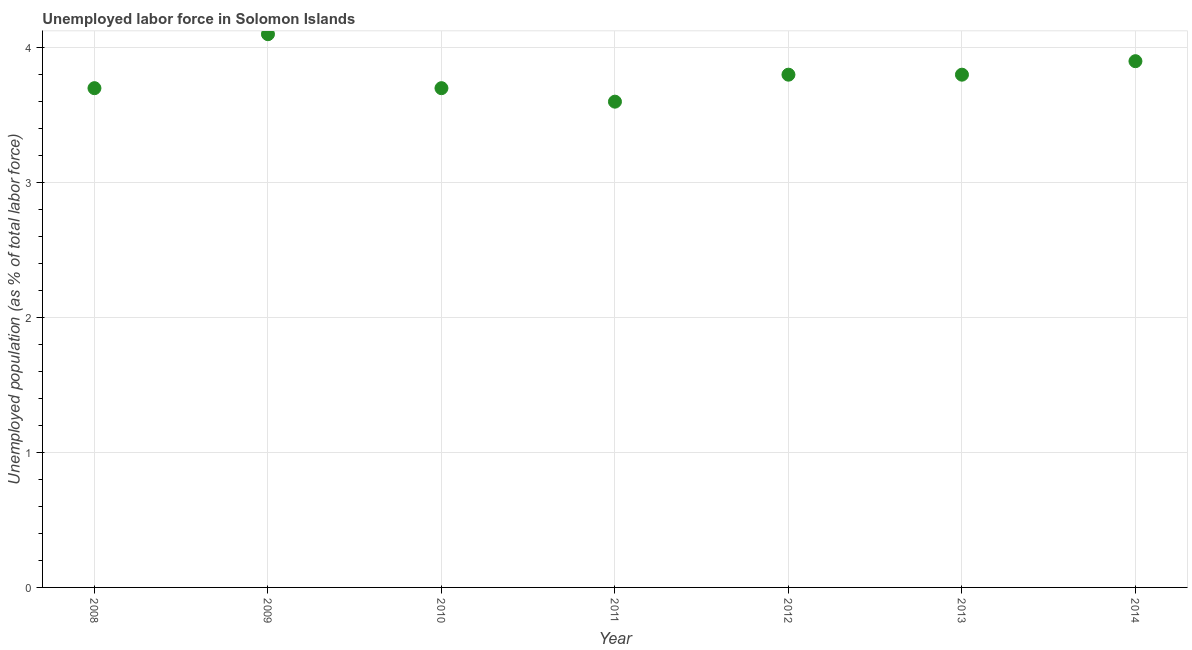What is the total unemployed population in 2014?
Keep it short and to the point. 3.9. Across all years, what is the maximum total unemployed population?
Your answer should be very brief. 4.1. Across all years, what is the minimum total unemployed population?
Your response must be concise. 3.6. In which year was the total unemployed population minimum?
Keep it short and to the point. 2011. What is the sum of the total unemployed population?
Your answer should be very brief. 26.6. What is the difference between the total unemployed population in 2010 and 2011?
Give a very brief answer. 0.1. What is the average total unemployed population per year?
Offer a terse response. 3.8. What is the median total unemployed population?
Offer a terse response. 3.8. What is the ratio of the total unemployed population in 2008 to that in 2014?
Your response must be concise. 0.95. Is the total unemployed population in 2013 less than that in 2014?
Your answer should be very brief. Yes. What is the difference between the highest and the second highest total unemployed population?
Offer a terse response. 0.2. What is the difference between the highest and the lowest total unemployed population?
Provide a short and direct response. 0.5. In how many years, is the total unemployed population greater than the average total unemployed population taken over all years?
Offer a very short reply. 2. Does the total unemployed population monotonically increase over the years?
Keep it short and to the point. No. How many dotlines are there?
Your answer should be very brief. 1. How many years are there in the graph?
Provide a succinct answer. 7. What is the difference between two consecutive major ticks on the Y-axis?
Ensure brevity in your answer.  1. Does the graph contain any zero values?
Provide a succinct answer. No. What is the title of the graph?
Offer a very short reply. Unemployed labor force in Solomon Islands. What is the label or title of the Y-axis?
Your answer should be very brief. Unemployed population (as % of total labor force). What is the Unemployed population (as % of total labor force) in 2008?
Your answer should be very brief. 3.7. What is the Unemployed population (as % of total labor force) in 2009?
Your answer should be compact. 4.1. What is the Unemployed population (as % of total labor force) in 2010?
Your response must be concise. 3.7. What is the Unemployed population (as % of total labor force) in 2011?
Offer a very short reply. 3.6. What is the Unemployed population (as % of total labor force) in 2012?
Your answer should be very brief. 3.8. What is the Unemployed population (as % of total labor force) in 2013?
Give a very brief answer. 3.8. What is the Unemployed population (as % of total labor force) in 2014?
Keep it short and to the point. 3.9. What is the difference between the Unemployed population (as % of total labor force) in 2008 and 2009?
Ensure brevity in your answer.  -0.4. What is the difference between the Unemployed population (as % of total labor force) in 2008 and 2014?
Provide a short and direct response. -0.2. What is the difference between the Unemployed population (as % of total labor force) in 2009 and 2010?
Offer a terse response. 0.4. What is the difference between the Unemployed population (as % of total labor force) in 2009 and 2013?
Your answer should be compact. 0.3. What is the difference between the Unemployed population (as % of total labor force) in 2009 and 2014?
Give a very brief answer. 0.2. What is the difference between the Unemployed population (as % of total labor force) in 2011 and 2012?
Ensure brevity in your answer.  -0.2. What is the difference between the Unemployed population (as % of total labor force) in 2012 and 2013?
Ensure brevity in your answer.  0. What is the difference between the Unemployed population (as % of total labor force) in 2013 and 2014?
Keep it short and to the point. -0.1. What is the ratio of the Unemployed population (as % of total labor force) in 2008 to that in 2009?
Your answer should be very brief. 0.9. What is the ratio of the Unemployed population (as % of total labor force) in 2008 to that in 2010?
Provide a short and direct response. 1. What is the ratio of the Unemployed population (as % of total labor force) in 2008 to that in 2011?
Give a very brief answer. 1.03. What is the ratio of the Unemployed population (as % of total labor force) in 2008 to that in 2013?
Your answer should be very brief. 0.97. What is the ratio of the Unemployed population (as % of total labor force) in 2008 to that in 2014?
Ensure brevity in your answer.  0.95. What is the ratio of the Unemployed population (as % of total labor force) in 2009 to that in 2010?
Ensure brevity in your answer.  1.11. What is the ratio of the Unemployed population (as % of total labor force) in 2009 to that in 2011?
Keep it short and to the point. 1.14. What is the ratio of the Unemployed population (as % of total labor force) in 2009 to that in 2012?
Ensure brevity in your answer.  1.08. What is the ratio of the Unemployed population (as % of total labor force) in 2009 to that in 2013?
Ensure brevity in your answer.  1.08. What is the ratio of the Unemployed population (as % of total labor force) in 2009 to that in 2014?
Keep it short and to the point. 1.05. What is the ratio of the Unemployed population (as % of total labor force) in 2010 to that in 2011?
Keep it short and to the point. 1.03. What is the ratio of the Unemployed population (as % of total labor force) in 2010 to that in 2013?
Keep it short and to the point. 0.97. What is the ratio of the Unemployed population (as % of total labor force) in 2010 to that in 2014?
Keep it short and to the point. 0.95. What is the ratio of the Unemployed population (as % of total labor force) in 2011 to that in 2012?
Your response must be concise. 0.95. What is the ratio of the Unemployed population (as % of total labor force) in 2011 to that in 2013?
Provide a short and direct response. 0.95. What is the ratio of the Unemployed population (as % of total labor force) in 2011 to that in 2014?
Your response must be concise. 0.92. What is the ratio of the Unemployed population (as % of total labor force) in 2012 to that in 2013?
Your answer should be compact. 1. What is the ratio of the Unemployed population (as % of total labor force) in 2012 to that in 2014?
Your response must be concise. 0.97. 